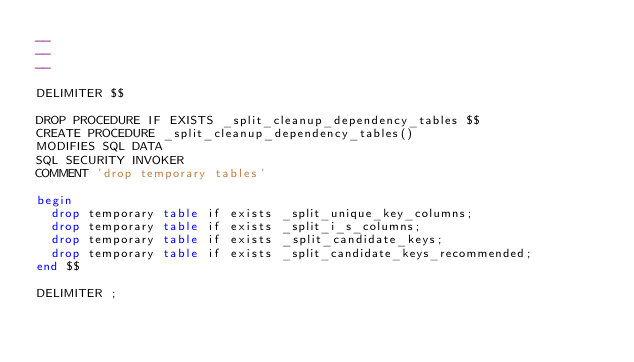<code> <loc_0><loc_0><loc_500><loc_500><_SQL_>-- 
-- 
-- 

DELIMITER $$

DROP PROCEDURE IF EXISTS _split_cleanup_dependency_tables $$
CREATE PROCEDURE _split_cleanup_dependency_tables() 
MODIFIES SQL DATA
SQL SECURITY INVOKER
COMMENT 'drop temporary tables'

begin
  drop temporary table if exists _split_unique_key_columns;
  drop temporary table if exists _split_i_s_columns;
  drop temporary table if exists _split_candidate_keys;
  drop temporary table if exists _split_candidate_keys_recommended;
end $$

DELIMITER ;
</code> 